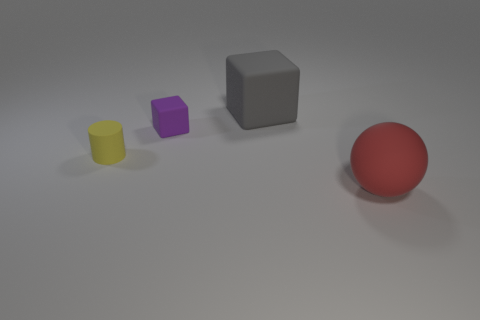Subtract all gray cubes. How many cubes are left? 1 Subtract 1 cubes. How many cubes are left? 1 Subtract all balls. How many objects are left? 3 Add 4 tiny matte objects. How many objects exist? 8 Add 3 green balls. How many green balls exist? 3 Subtract 0 green cylinders. How many objects are left? 4 Subtract all brown balls. Subtract all brown blocks. How many balls are left? 1 Subtract all yellow spheres. How many yellow blocks are left? 0 Subtract all gray things. Subtract all large green matte spheres. How many objects are left? 3 Add 1 big red objects. How many big red objects are left? 2 